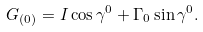Convert formula to latex. <formula><loc_0><loc_0><loc_500><loc_500>G _ { ( 0 ) } = I \cos \gamma ^ { 0 } + \Gamma _ { 0 } \sin \gamma ^ { 0 } .</formula> 